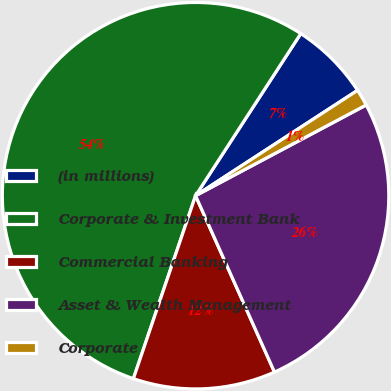<chart> <loc_0><loc_0><loc_500><loc_500><pie_chart><fcel>(in millions)<fcel>Corporate & Investment Bank<fcel>Commercial Banking<fcel>Asset & Wealth Management<fcel>Corporate<nl><fcel>6.66%<fcel>53.95%<fcel>11.91%<fcel>26.08%<fcel>1.4%<nl></chart> 